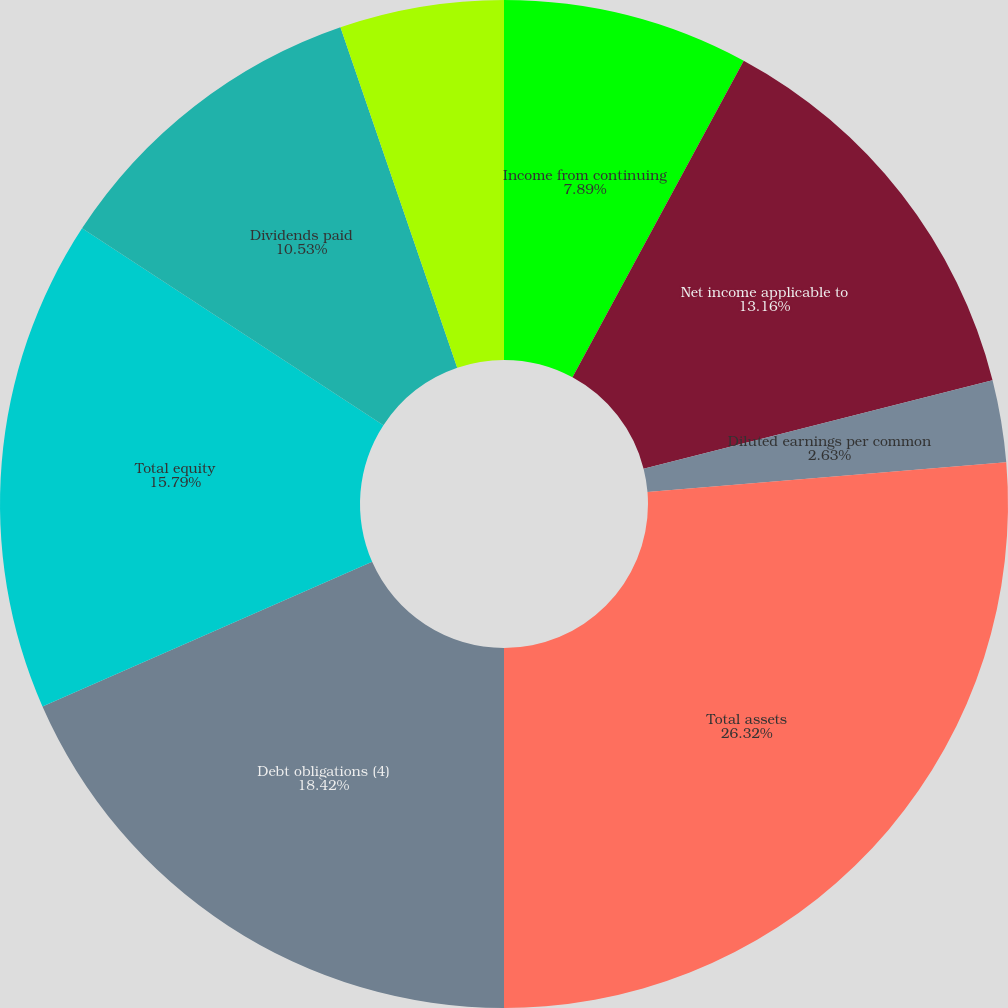Convert chart to OTSL. <chart><loc_0><loc_0><loc_500><loc_500><pie_chart><fcel>Income from continuing<fcel>Net income applicable to<fcel>Basic earnings per common<fcel>Diluted earnings per common<fcel>Total assets<fcel>Debt obligations (4)<fcel>Total equity<fcel>Dividends paid<fcel>Dividends paid per common<nl><fcel>7.89%<fcel>13.16%<fcel>0.0%<fcel>2.63%<fcel>26.32%<fcel>18.42%<fcel>15.79%<fcel>10.53%<fcel>5.26%<nl></chart> 